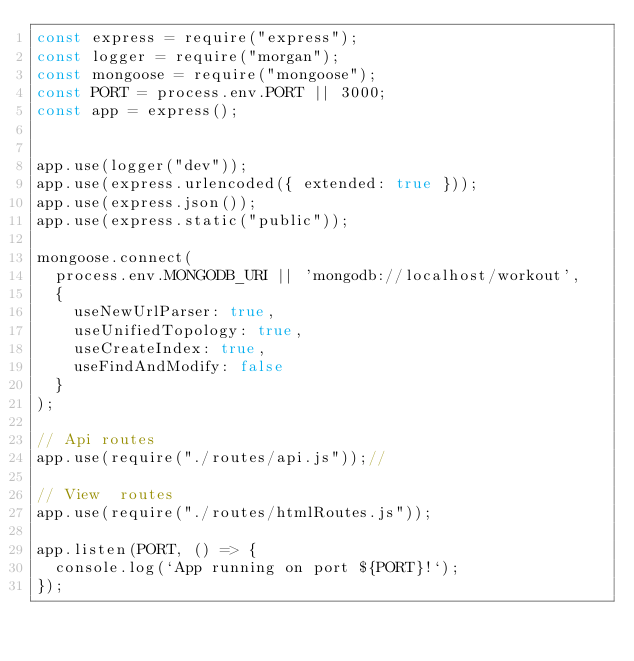Convert code to text. <code><loc_0><loc_0><loc_500><loc_500><_JavaScript_>const express = require("express");
const logger = require("morgan");
const mongoose = require("mongoose");
const PORT = process.env.PORT || 3000;
const app = express();


app.use(logger("dev"));
app.use(express.urlencoded({ extended: true }));
app.use(express.json());
app.use(express.static("public"));

mongoose.connect(
  process.env.MONGODB_URI || 'mongodb://localhost/workout',
  {
    useNewUrlParser: true,
    useUnifiedTopology: true,
    useCreateIndex: true,
    useFindAndModify: false
  }
);

// Api routes
app.use(require("./routes/api.js"));// 

// View  routes
app.use(require("./routes/htmlRoutes.js"));

app.listen(PORT, () => {
  console.log(`App running on port ${PORT}!`);
});
</code> 